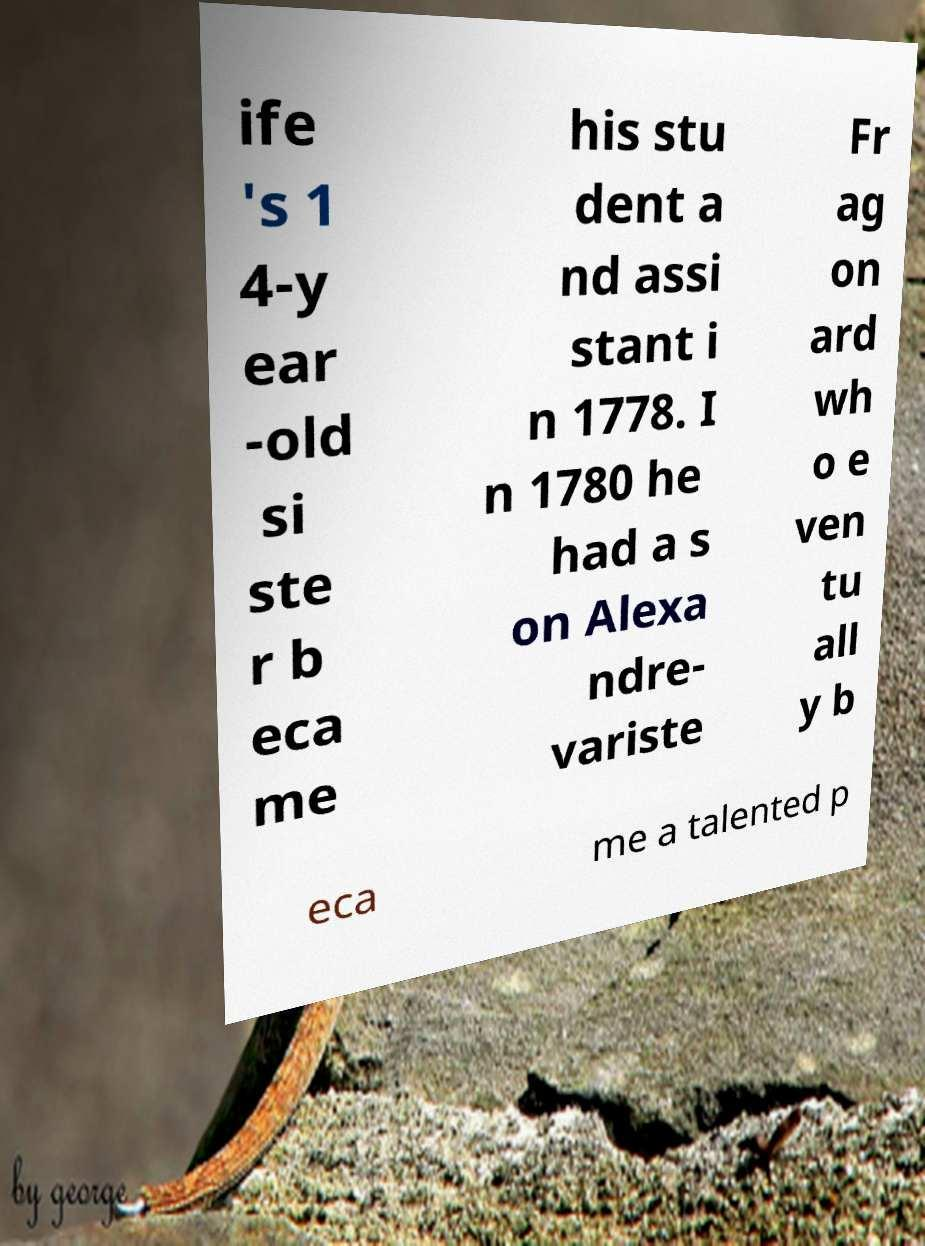I need the written content from this picture converted into text. Can you do that? ife 's 1 4-y ear -old si ste r b eca me his stu dent a nd assi stant i n 1778. I n 1780 he had a s on Alexa ndre- variste Fr ag on ard wh o e ven tu all y b eca me a talented p 